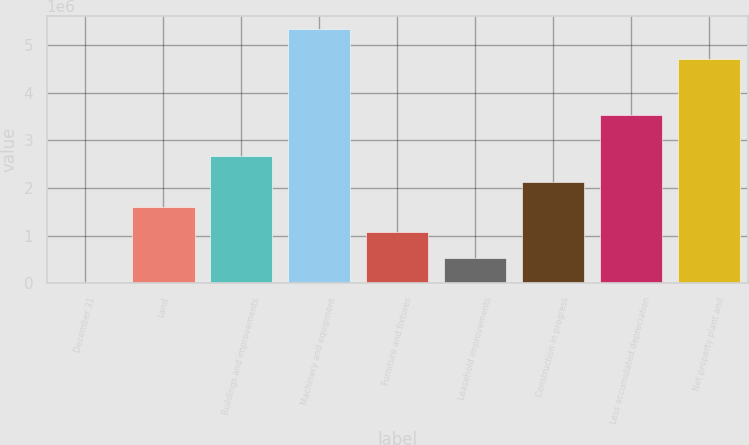<chart> <loc_0><loc_0><loc_500><loc_500><bar_chart><fcel>December 31<fcel>Land<fcel>Buildings and improvements<fcel>Machinery and equipment<fcel>Furniture and fixtures<fcel>Leasehold improvements<fcel>Construction in progress<fcel>Less accumulated depreciation<fcel>Net property plant and<nl><fcel>2018<fcel>1.60163e+06<fcel>2.66804e+06<fcel>5.33406e+06<fcel>1.06843e+06<fcel>535222<fcel>2.13483e+06<fcel>3.52717e+06<fcel>4.6999e+06<nl></chart> 